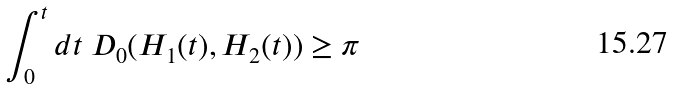<formula> <loc_0><loc_0><loc_500><loc_500>\int _ { 0 } ^ { t } d t \ D _ { 0 } ( H _ { 1 } ( t ) , H _ { 2 } ( t ) ) \geq \pi</formula> 